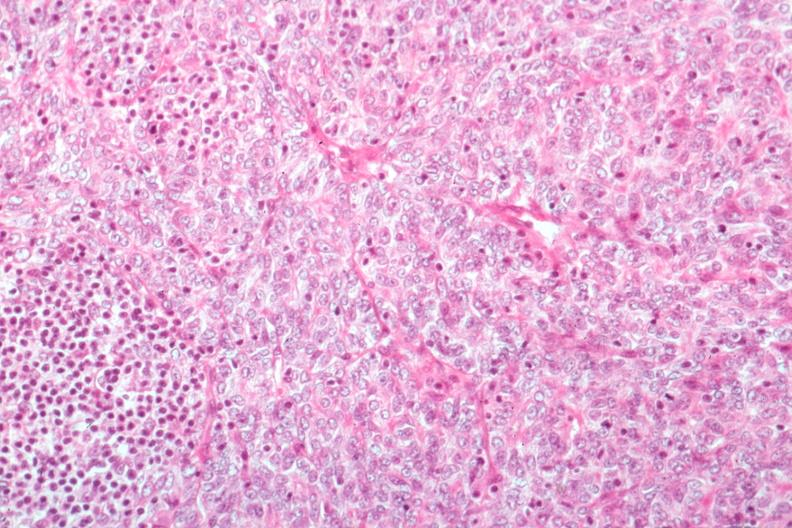s thymus present?
Answer the question using a single word or phrase. Yes 